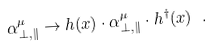<formula> <loc_0><loc_0><loc_500><loc_500>\alpha _ { \perp , \| } ^ { \mu } \rightarrow h ( x ) \cdot \alpha _ { \perp , \| } ^ { \mu } \cdot h ^ { \dag } ( x ) \ .</formula> 